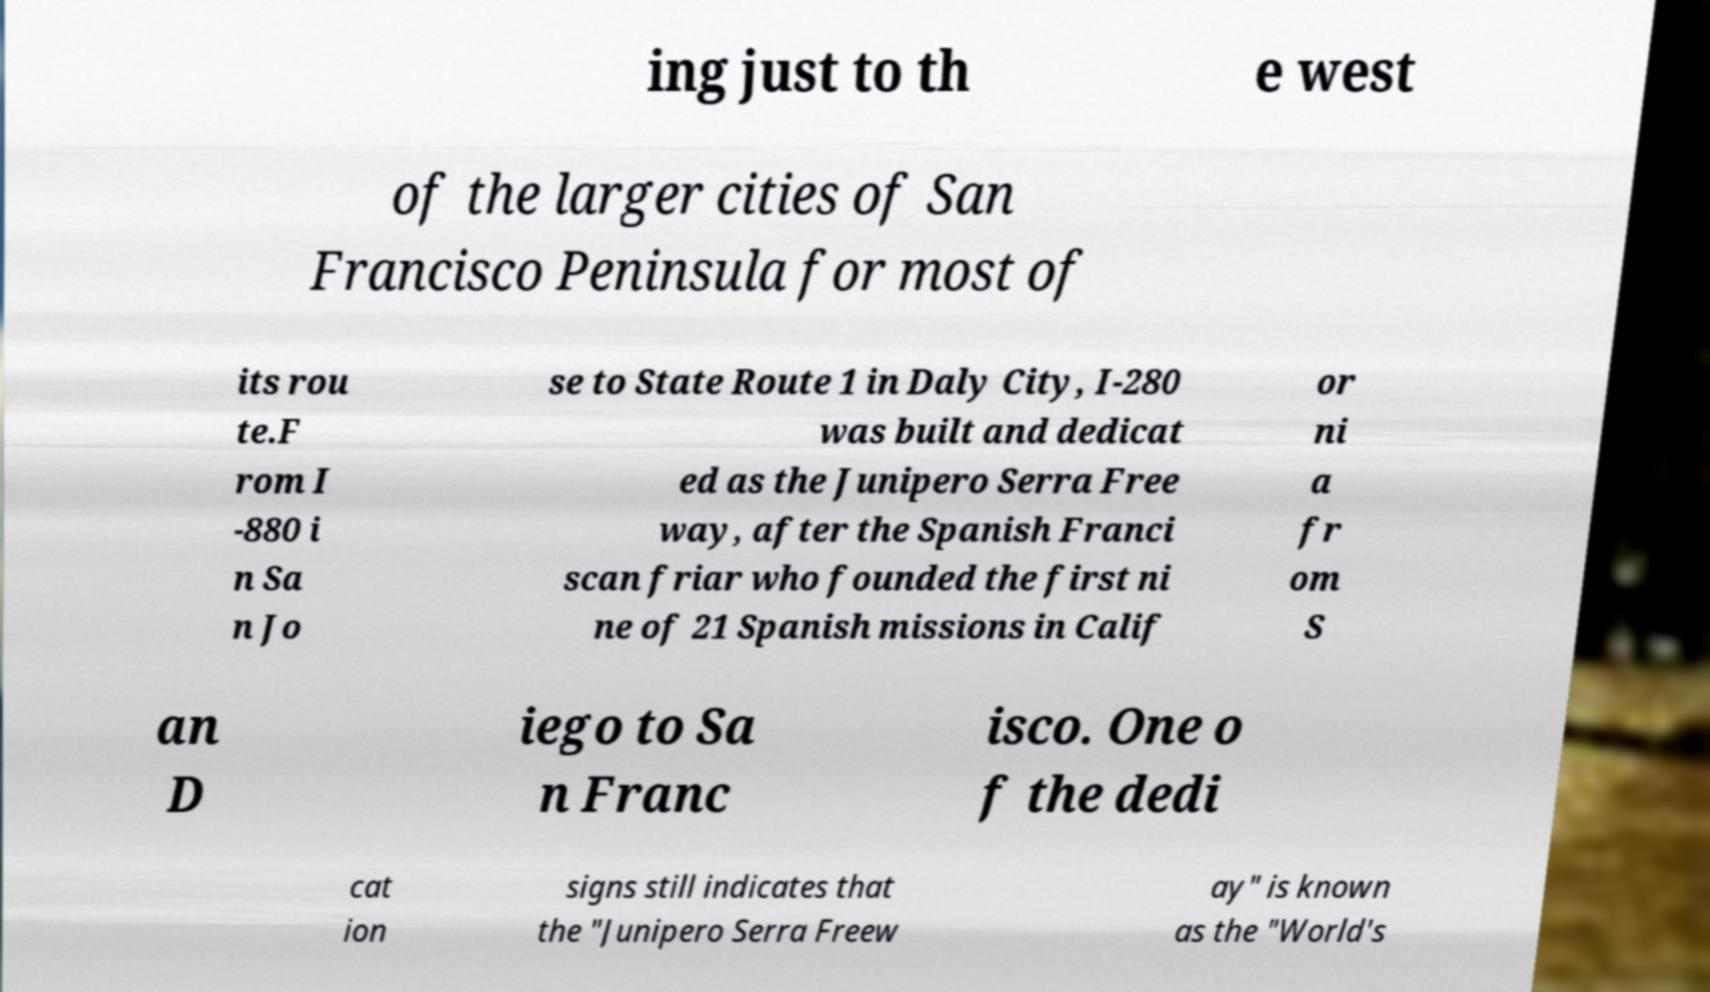What messages or text are displayed in this image? I need them in a readable, typed format. ing just to th e west of the larger cities of San Francisco Peninsula for most of its rou te.F rom I -880 i n Sa n Jo se to State Route 1 in Daly City, I-280 was built and dedicat ed as the Junipero Serra Free way, after the Spanish Franci scan friar who founded the first ni ne of 21 Spanish missions in Calif or ni a fr om S an D iego to Sa n Franc isco. One o f the dedi cat ion signs still indicates that the "Junipero Serra Freew ay" is known as the "World's 